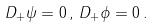<formula> <loc_0><loc_0><loc_500><loc_500>D _ { + } \psi = 0 \, , \, D _ { + } \phi = 0 \, .</formula> 